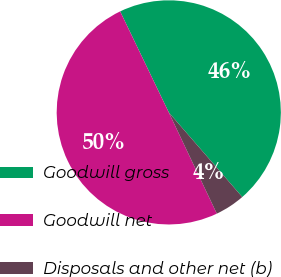Convert chart. <chart><loc_0><loc_0><loc_500><loc_500><pie_chart><fcel>Goodwill gross<fcel>Goodwill net<fcel>Disposals and other net (b)<nl><fcel>45.76%<fcel>49.91%<fcel>4.33%<nl></chart> 